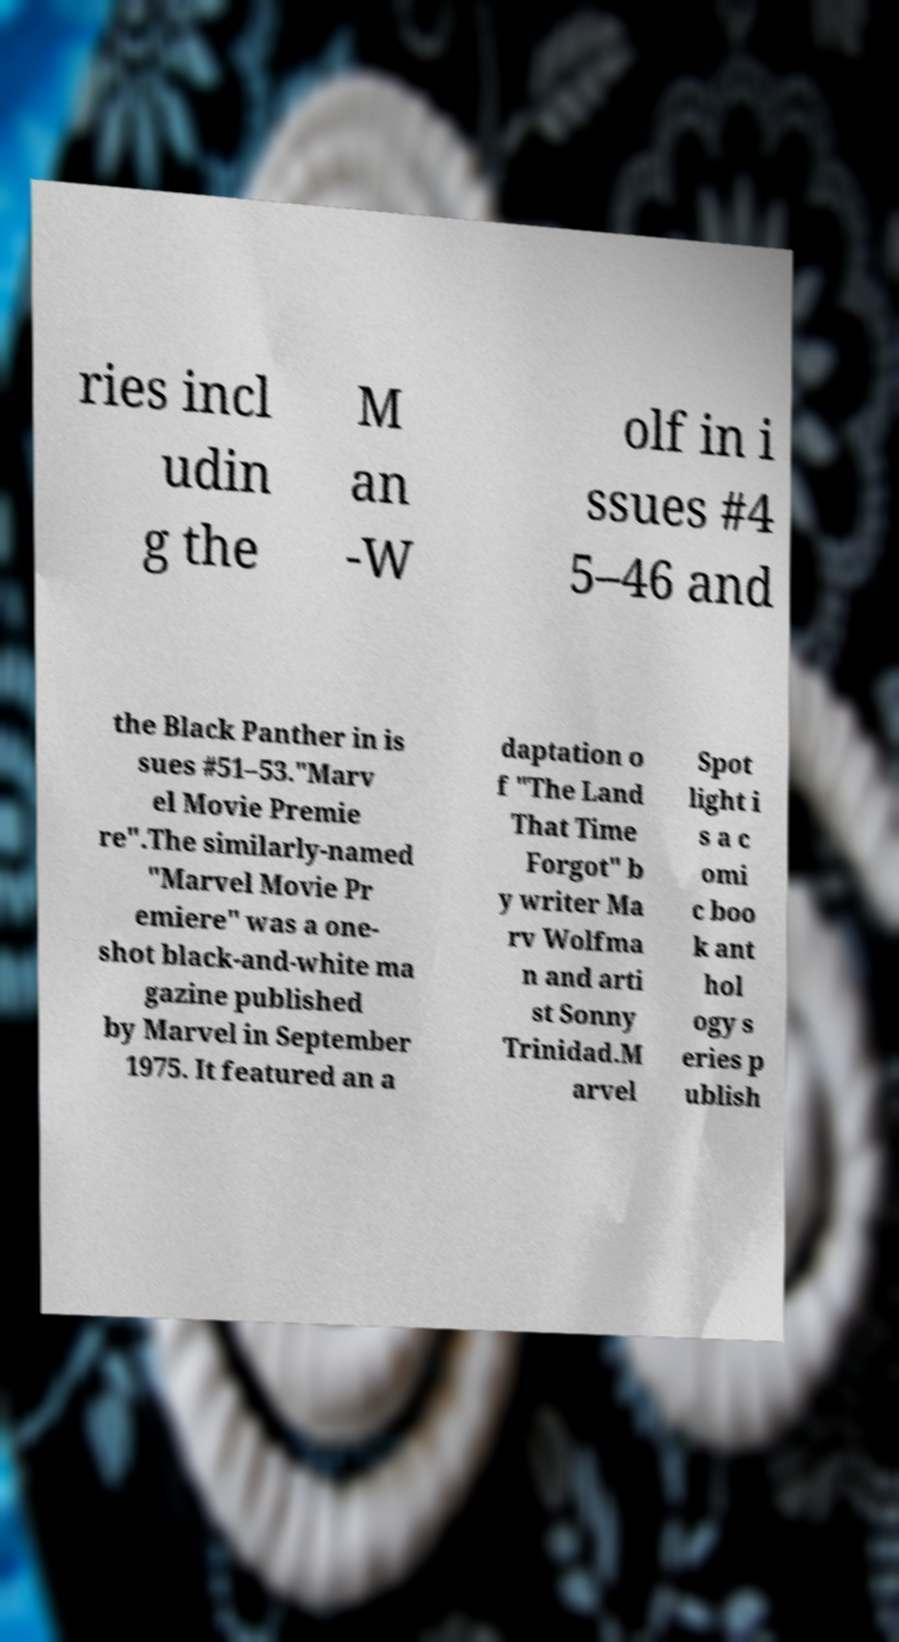Please read and relay the text visible in this image. What does it say? ries incl udin g the M an -W olf in i ssues #4 5–46 and the Black Panther in is sues #51–53."Marv el Movie Premie re".The similarly-named "Marvel Movie Pr emiere" was a one- shot black-and-white ma gazine published by Marvel in September 1975. It featured an a daptation o f "The Land That Time Forgot" b y writer Ma rv Wolfma n and arti st Sonny Trinidad.M arvel Spot light i s a c omi c boo k ant hol ogy s eries p ublish 